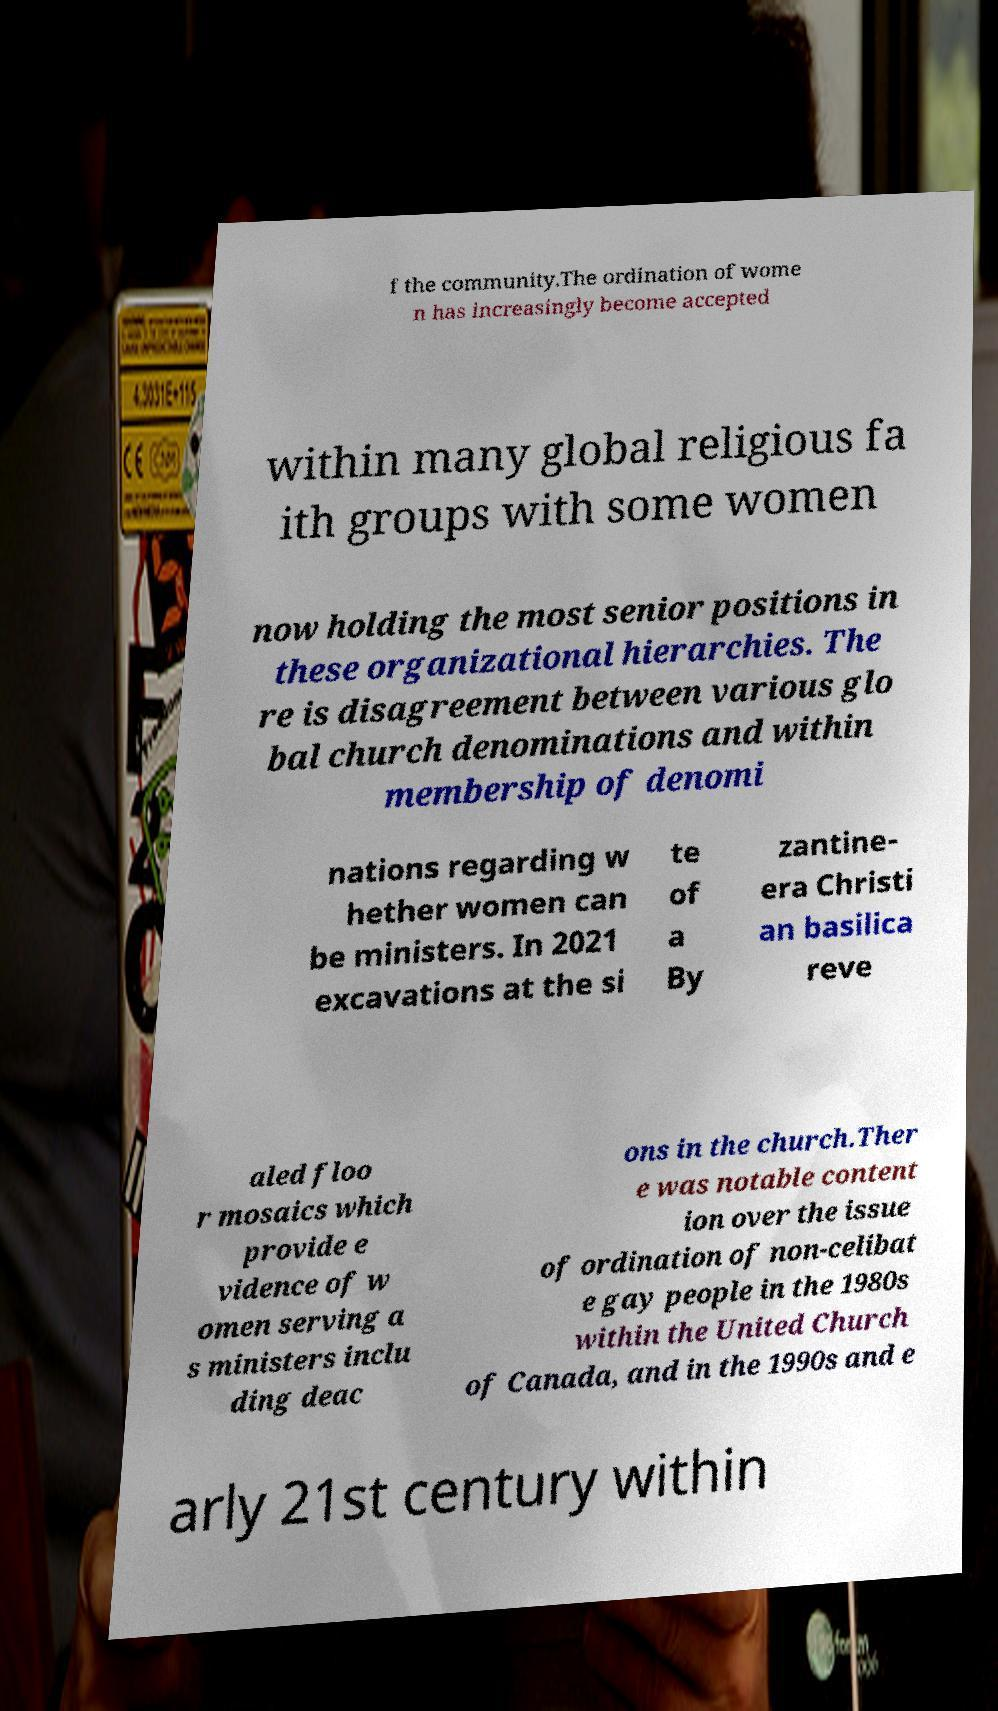Could you extract and type out the text from this image? f the community.The ordination of wome n has increasingly become accepted within many global religious fa ith groups with some women now holding the most senior positions in these organizational hierarchies. The re is disagreement between various glo bal church denominations and within membership of denomi nations regarding w hether women can be ministers. In 2021 excavations at the si te of a By zantine- era Christi an basilica reve aled floo r mosaics which provide e vidence of w omen serving a s ministers inclu ding deac ons in the church.Ther e was notable content ion over the issue of ordination of non-celibat e gay people in the 1980s within the United Church of Canada, and in the 1990s and e arly 21st century within 